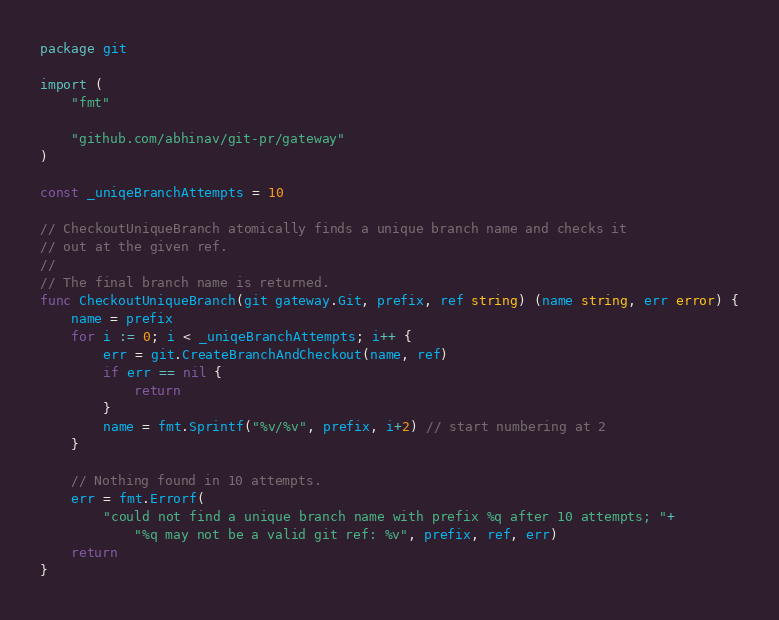<code> <loc_0><loc_0><loc_500><loc_500><_Go_>package git

import (
	"fmt"

	"github.com/abhinav/git-pr/gateway"
)

const _uniqeBranchAttempts = 10

// CheckoutUniqueBranch atomically finds a unique branch name and checks it
// out at the given ref.
//
// The final branch name is returned.
func CheckoutUniqueBranch(git gateway.Git, prefix, ref string) (name string, err error) {
	name = prefix
	for i := 0; i < _uniqeBranchAttempts; i++ {
		err = git.CreateBranchAndCheckout(name, ref)
		if err == nil {
			return
		}
		name = fmt.Sprintf("%v/%v", prefix, i+2) // start numbering at 2
	}

	// Nothing found in 10 attempts.
	err = fmt.Errorf(
		"could not find a unique branch name with prefix %q after 10 attempts; "+
			"%q may not be a valid git ref: %v", prefix, ref, err)
	return
}
</code> 